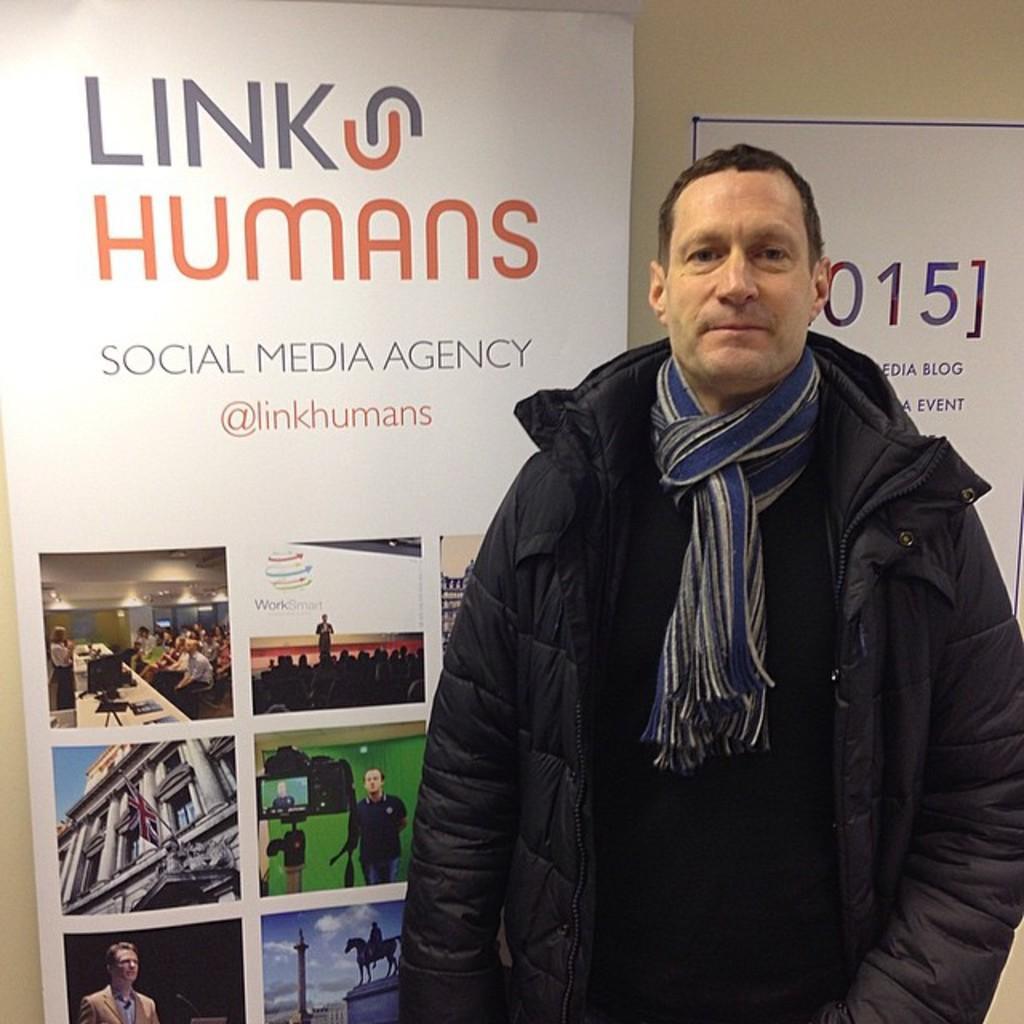Describe this image in one or two sentences. In the image there is a man standing in the foreground and behind him there are two posters. 